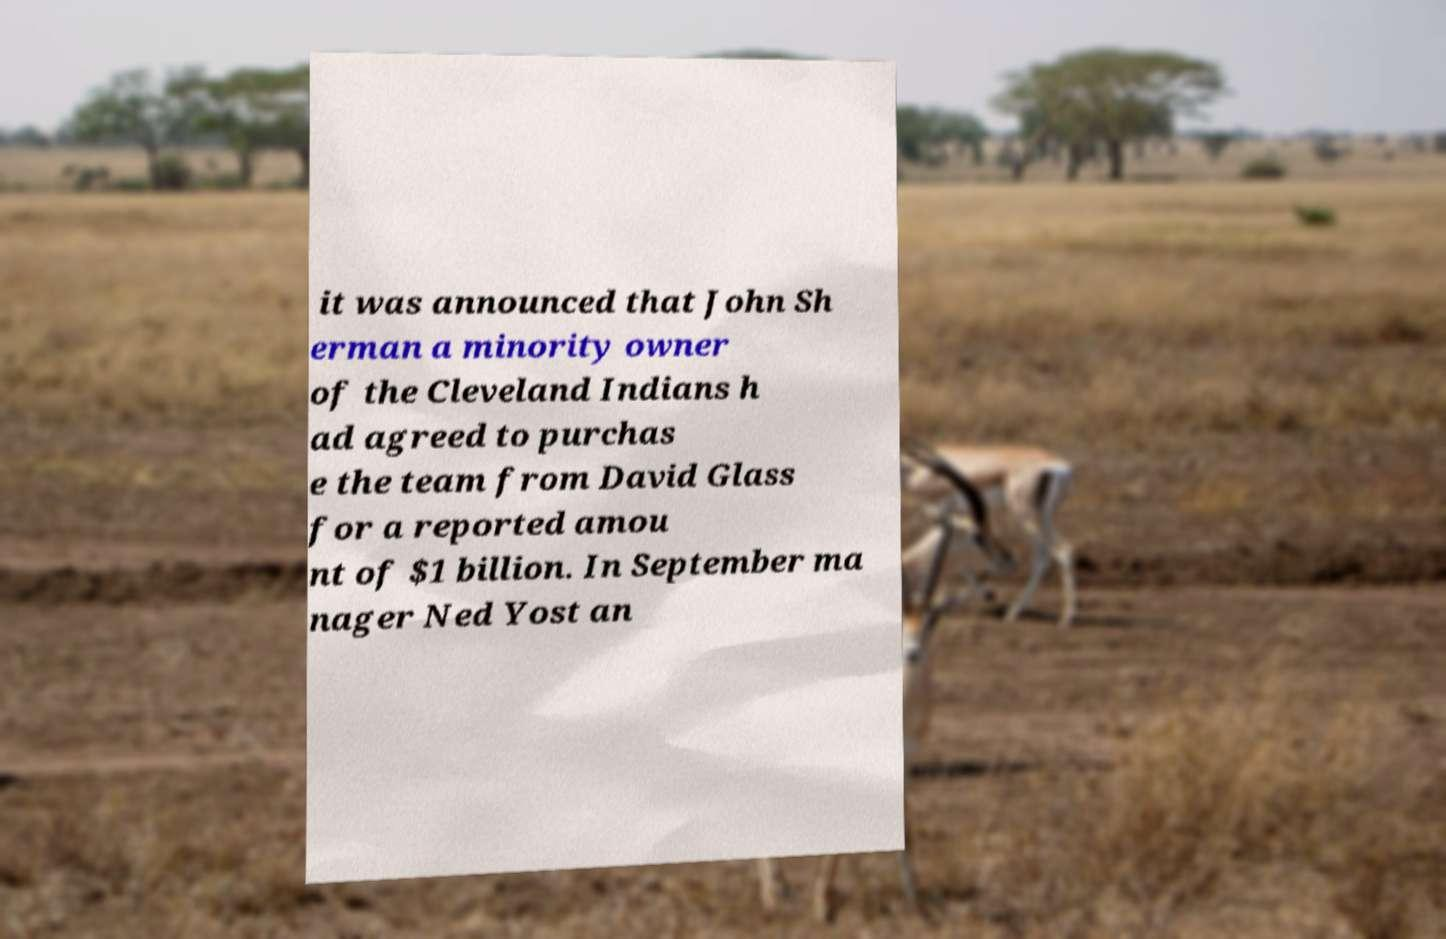Can you accurately transcribe the text from the provided image for me? it was announced that John Sh erman a minority owner of the Cleveland Indians h ad agreed to purchas e the team from David Glass for a reported amou nt of $1 billion. In September ma nager Ned Yost an 